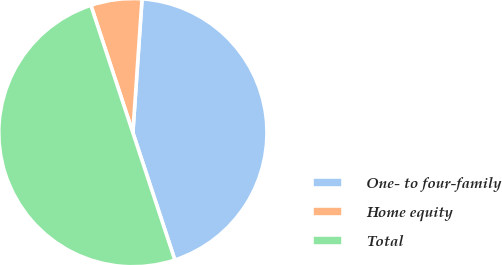Convert chart to OTSL. <chart><loc_0><loc_0><loc_500><loc_500><pie_chart><fcel>One- to four-family<fcel>Home equity<fcel>Total<nl><fcel>43.84%<fcel>6.16%<fcel>50.0%<nl></chart> 